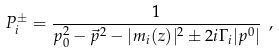<formula> <loc_0><loc_0><loc_500><loc_500>P _ { i } ^ { \pm } = \frac { 1 } { p _ { 0 } ^ { 2 } - \vec { p } ^ { 2 } - | m _ { i } ( z ) | ^ { 2 } \pm 2 i \Gamma _ { i } | p ^ { 0 } | } \ ,</formula> 